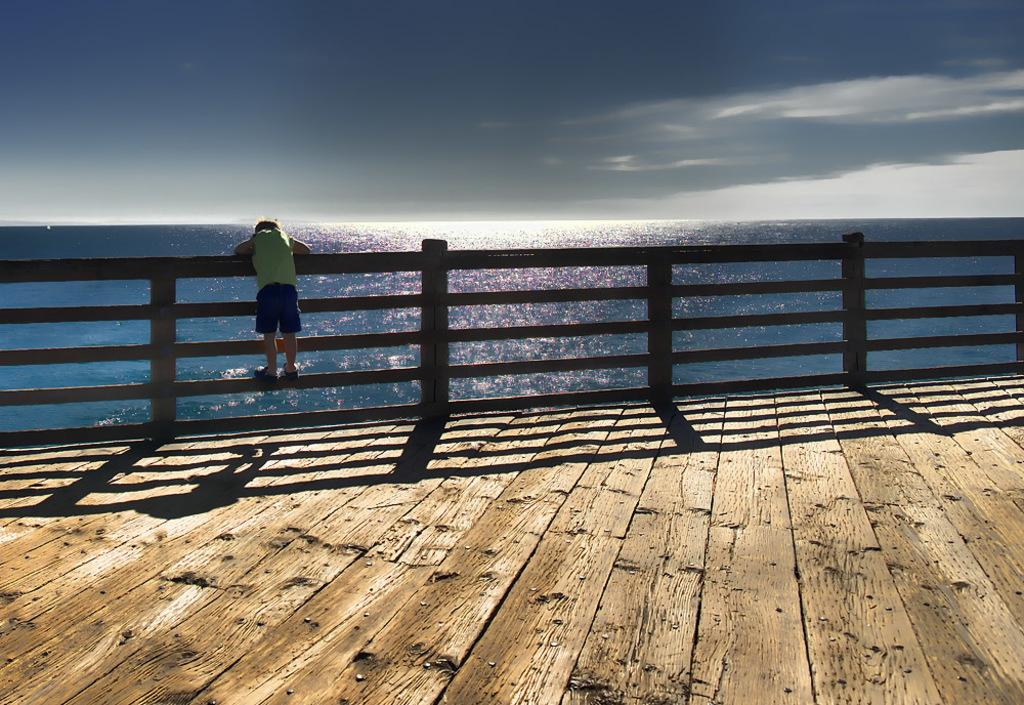What is the condition of the sky in the image? The sky is cloudy in the image. What can be seen in the image besides the sky? There is a fence, a person, and water visible in the image. What might be used to enclose or separate areas in the image? The fence can be used to enclose or separate areas in the image. What is the person in the image doing? The facts provided do not specify what the person is doing in the image. What type of pot is being used for observation in the image? There is no pot present in the image, and therefore no such activity can be observed. 